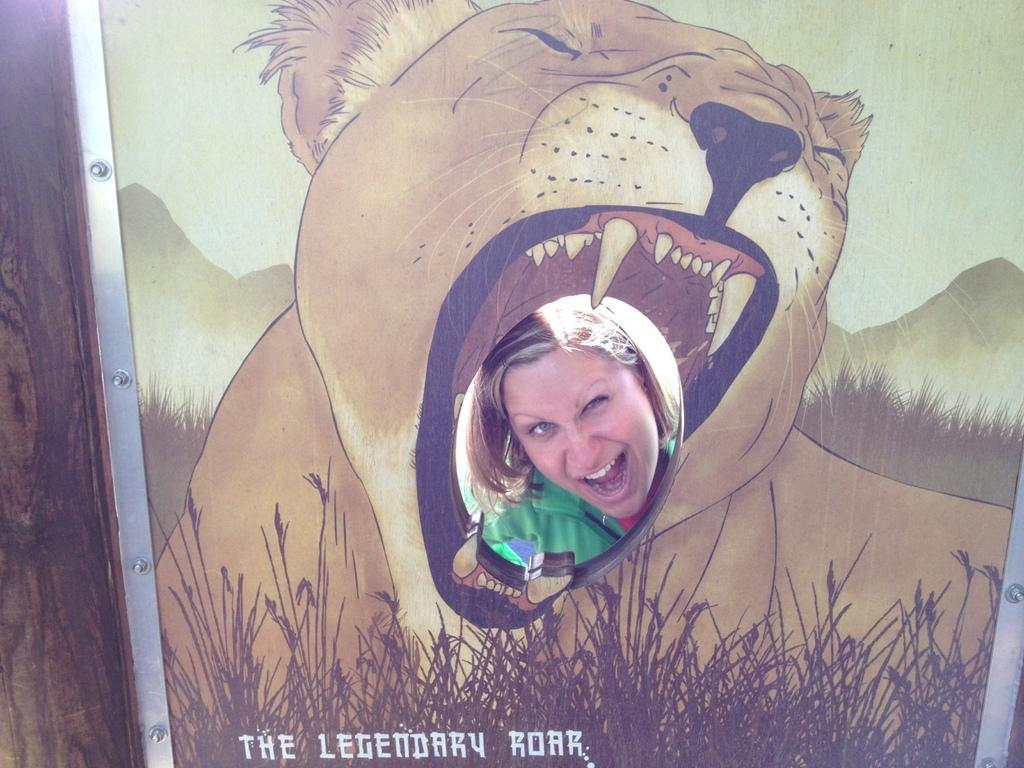What type of artwork is depicted in the image? The image is a painting. What animal can be seen in the painting? There is a tiger sitting on the grass in the painting. Are there any human figures in the painting? Yes, there is a person image in the painting. What can be seen in the distance in the painting? There are hills visible in the background of the painting. Can you tell me where the sister is located in the painting? There is no mention of a sister in the painting, so it cannot be determined where she might be located. 